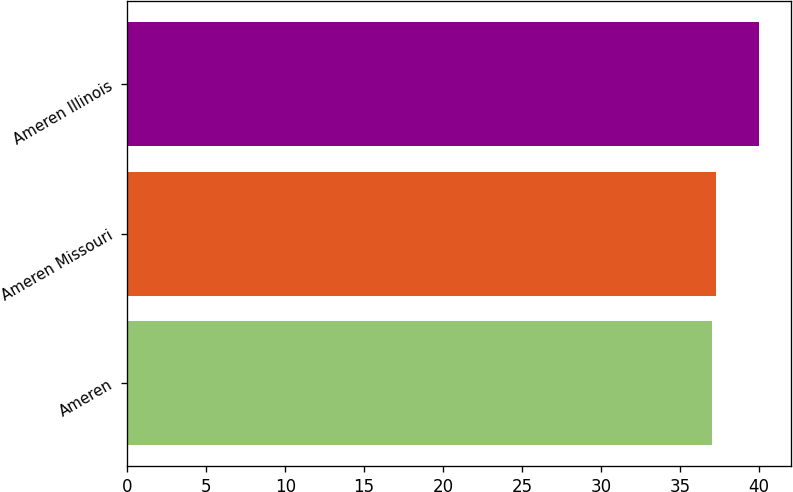Convert chart. <chart><loc_0><loc_0><loc_500><loc_500><bar_chart><fcel>Ameren<fcel>Ameren Missouri<fcel>Ameren Illinois<nl><fcel>37<fcel>37.3<fcel>40<nl></chart> 